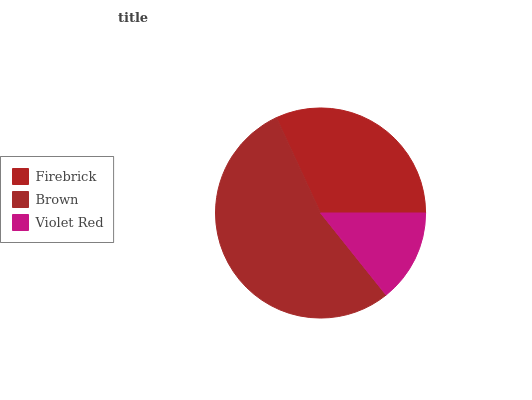Is Violet Red the minimum?
Answer yes or no. Yes. Is Brown the maximum?
Answer yes or no. Yes. Is Brown the minimum?
Answer yes or no. No. Is Violet Red the maximum?
Answer yes or no. No. Is Brown greater than Violet Red?
Answer yes or no. Yes. Is Violet Red less than Brown?
Answer yes or no. Yes. Is Violet Red greater than Brown?
Answer yes or no. No. Is Brown less than Violet Red?
Answer yes or no. No. Is Firebrick the high median?
Answer yes or no. Yes. Is Firebrick the low median?
Answer yes or no. Yes. Is Brown the high median?
Answer yes or no. No. Is Violet Red the low median?
Answer yes or no. No. 